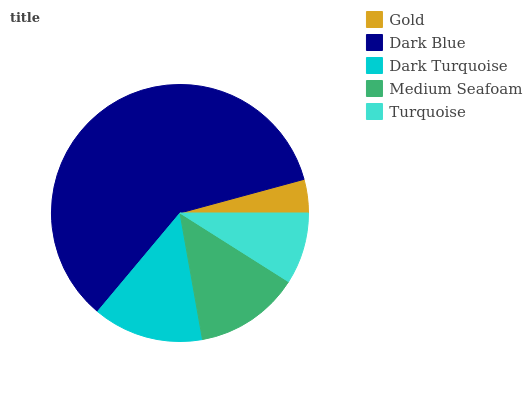Is Gold the minimum?
Answer yes or no. Yes. Is Dark Blue the maximum?
Answer yes or no. Yes. Is Dark Turquoise the minimum?
Answer yes or no. No. Is Dark Turquoise the maximum?
Answer yes or no. No. Is Dark Blue greater than Dark Turquoise?
Answer yes or no. Yes. Is Dark Turquoise less than Dark Blue?
Answer yes or no. Yes. Is Dark Turquoise greater than Dark Blue?
Answer yes or no. No. Is Dark Blue less than Dark Turquoise?
Answer yes or no. No. Is Medium Seafoam the high median?
Answer yes or no. Yes. Is Medium Seafoam the low median?
Answer yes or no. Yes. Is Dark Blue the high median?
Answer yes or no. No. Is Dark Blue the low median?
Answer yes or no. No. 